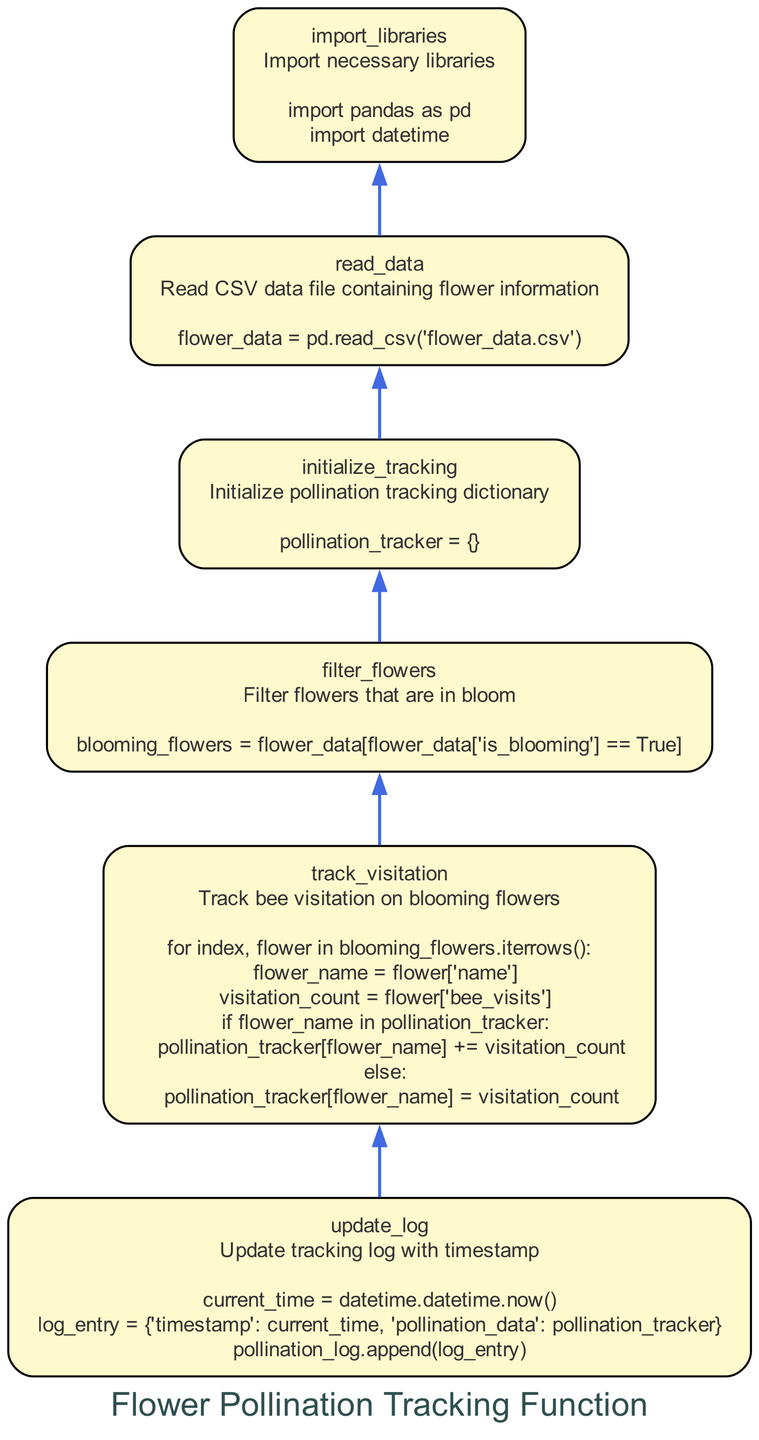what is the first step in the flowchart? The first step in the flowchart, which is the bottom-most node, is to import necessary libraries. This is indicated by the "import_libraries" node.
Answer: import necessary libraries how many nodes are present in the flowchart? The flowchart consists of six nodes, each representing a different step in the flower pollination tracking process. Counting all the labeled steps, we find a total of six distinct elements.
Answer: six which node details the action of reading a CSV file? The node labeled "read_data" specifically describes the action of reading a CSV file that contains flower information, as indicated in its description.
Answer: read_csv what is the relationship between tracking bee visitation and blooming flowers? The "track_visitation" node is dependent on the "filter_flowers" node. First, blooming flowers are identified, and then the visitation is tracked for those specific flowers.
Answer: tracking bee visitation is dependent on filtering blooming flowers what is updated with a timestamp in the flowchart? The "update_log" node updates the tracking log with a timestamp, which includes the current time and the current pollination data. This is specified in its details showing log entry creation.
Answer: tracking log how is visitation counted for each flower? In the "track_visitation" step, for each flower that is blooming, the visitation count is obtained from the 'bee_visits' column in the CSV data, accumulating it in the pollination_tracker.
Answer: from the 'bee_visits' column what data structure is initialized for pollination tracking? The "initialize_tracking" node indicates that a dictionary is initialized to keep track of the pollination data as described.
Answer: dictionary what is the purpose of importing the datetime library? The datetime library is imported to obtain the current time, which is necessary for timestamping the entries in the pollination tracking log, as indicated in the "update_log" node.
Answer: timestamping log entries 